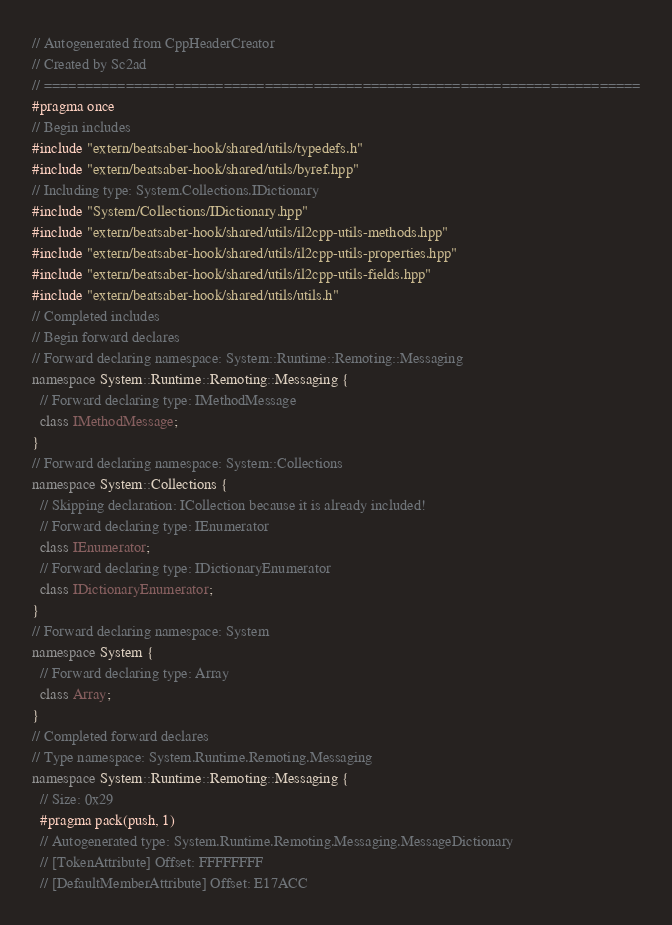Convert code to text. <code><loc_0><loc_0><loc_500><loc_500><_C++_>// Autogenerated from CppHeaderCreator
// Created by Sc2ad
// =========================================================================
#pragma once
// Begin includes
#include "extern/beatsaber-hook/shared/utils/typedefs.h"
#include "extern/beatsaber-hook/shared/utils/byref.hpp"
// Including type: System.Collections.IDictionary
#include "System/Collections/IDictionary.hpp"
#include "extern/beatsaber-hook/shared/utils/il2cpp-utils-methods.hpp"
#include "extern/beatsaber-hook/shared/utils/il2cpp-utils-properties.hpp"
#include "extern/beatsaber-hook/shared/utils/il2cpp-utils-fields.hpp"
#include "extern/beatsaber-hook/shared/utils/utils.h"
// Completed includes
// Begin forward declares
// Forward declaring namespace: System::Runtime::Remoting::Messaging
namespace System::Runtime::Remoting::Messaging {
  // Forward declaring type: IMethodMessage
  class IMethodMessage;
}
// Forward declaring namespace: System::Collections
namespace System::Collections {
  // Skipping declaration: ICollection because it is already included!
  // Forward declaring type: IEnumerator
  class IEnumerator;
  // Forward declaring type: IDictionaryEnumerator
  class IDictionaryEnumerator;
}
// Forward declaring namespace: System
namespace System {
  // Forward declaring type: Array
  class Array;
}
// Completed forward declares
// Type namespace: System.Runtime.Remoting.Messaging
namespace System::Runtime::Remoting::Messaging {
  // Size: 0x29
  #pragma pack(push, 1)
  // Autogenerated type: System.Runtime.Remoting.Messaging.MessageDictionary
  // [TokenAttribute] Offset: FFFFFFFF
  // [DefaultMemberAttribute] Offset: E17ACC</code> 